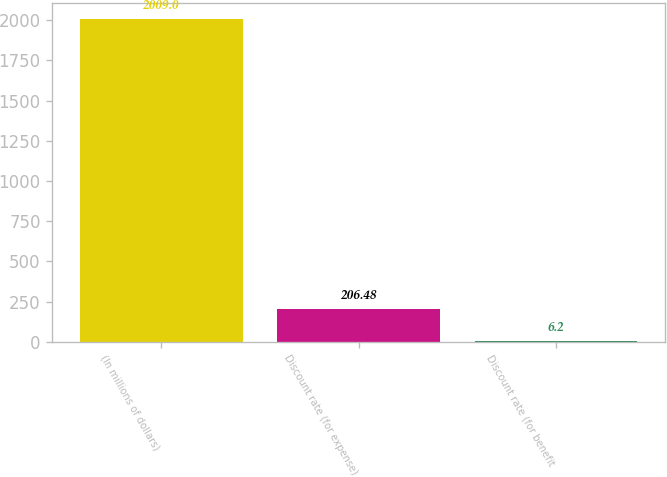Convert chart. <chart><loc_0><loc_0><loc_500><loc_500><bar_chart><fcel>(In millions of dollars)<fcel>Discount rate (for expense)<fcel>Discount rate (for benefit<nl><fcel>2009<fcel>206.48<fcel>6.2<nl></chart> 